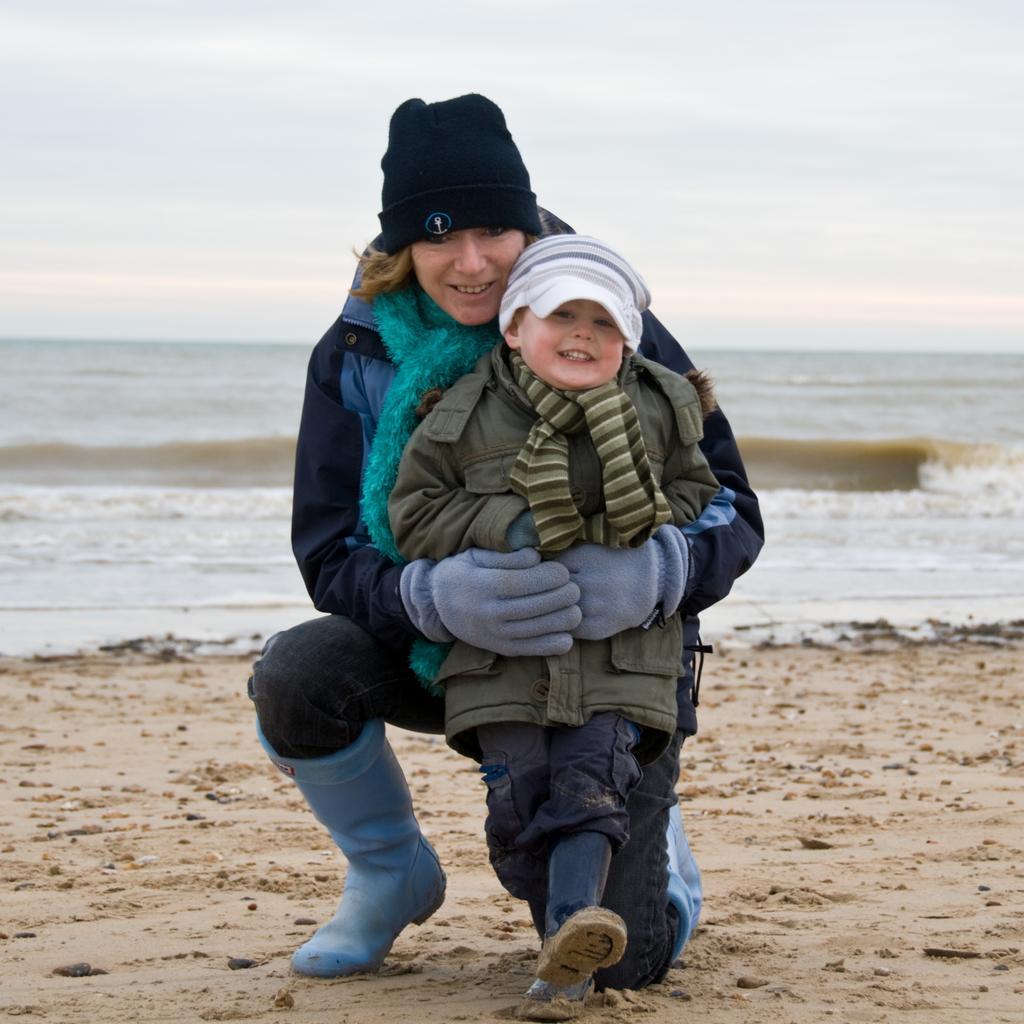Describe this image in one or two sentences. This is a beach. Here I can see a woman holding a baby in the hands and sitting on the knees. Both are wearing jackets, caps on their heads, smiling and giving pose for the picture. In the background there is an ocean. At the top of the image I can see the sky. 